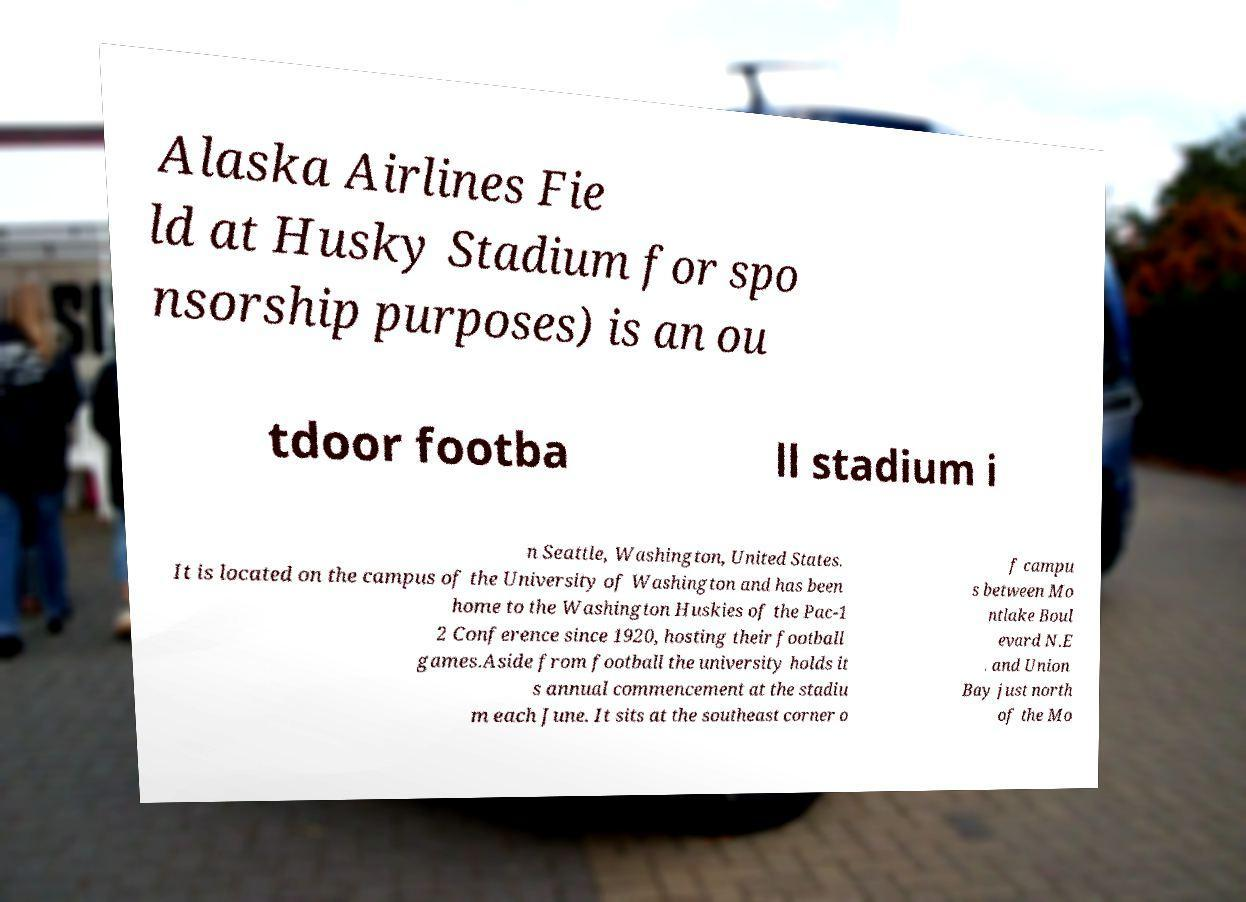Could you extract and type out the text from this image? Alaska Airlines Fie ld at Husky Stadium for spo nsorship purposes) is an ou tdoor footba ll stadium i n Seattle, Washington, United States. It is located on the campus of the University of Washington and has been home to the Washington Huskies of the Pac-1 2 Conference since 1920, hosting their football games.Aside from football the university holds it s annual commencement at the stadiu m each June. It sits at the southeast corner o f campu s between Mo ntlake Boul evard N.E . and Union Bay just north of the Mo 